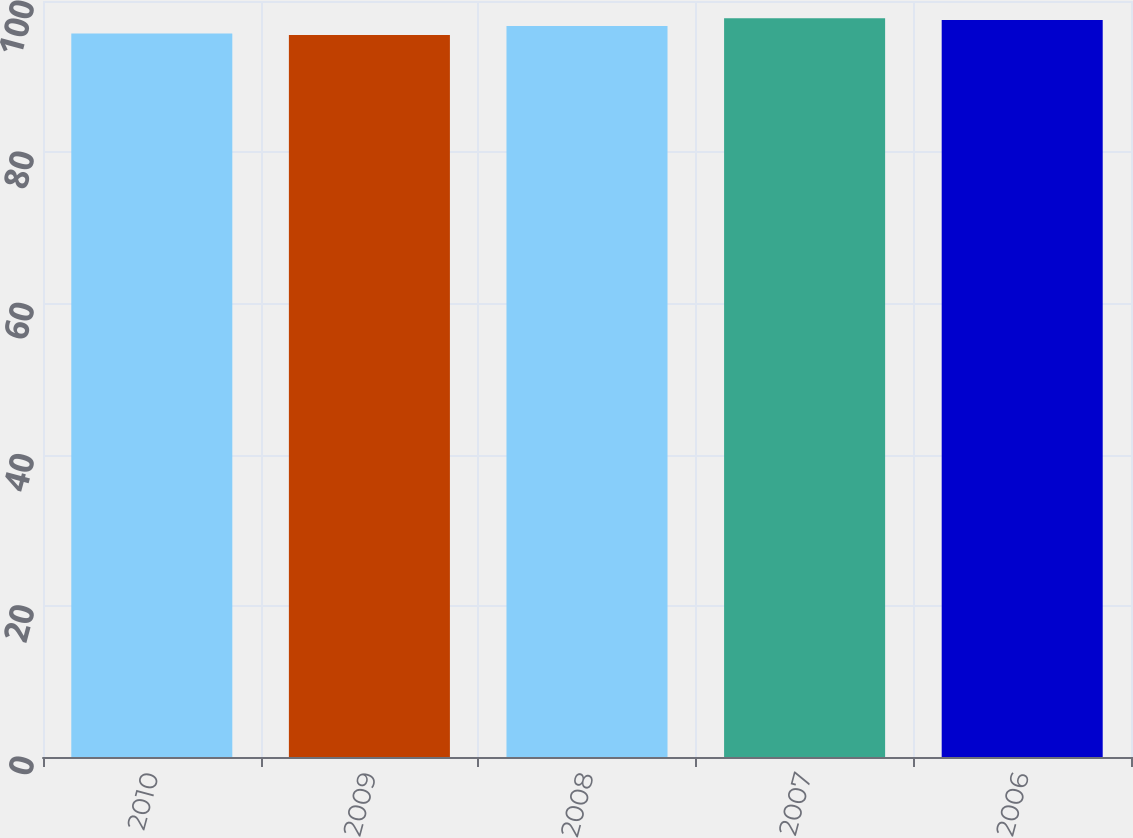Convert chart to OTSL. <chart><loc_0><loc_0><loc_500><loc_500><bar_chart><fcel>2010<fcel>2009<fcel>2008<fcel>2007<fcel>2006<nl><fcel>95.71<fcel>95.5<fcel>96.7<fcel>97.71<fcel>97.5<nl></chart> 